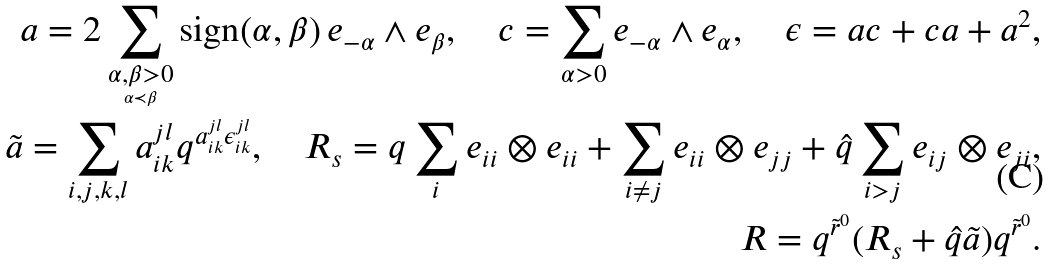<formula> <loc_0><loc_0><loc_500><loc_500>a = 2 \sum _ { \underset { \alpha \prec \beta } { \alpha , \beta > 0 } } \text {sign} ( \alpha , \beta ) \, e _ { - \alpha } \wedge e _ { \beta } , \quad c = \sum _ { \alpha > 0 } e _ { - \alpha } \wedge e _ { \alpha } , \quad \epsilon = a c + c a + a ^ { 2 } , \\ \tilde { a } = \sum _ { i , j , k , l } a _ { i k } ^ { j l } q ^ { a _ { i k } ^ { j l } \epsilon _ { i k } ^ { j l } } , \quad R _ { s } = q \sum _ { i } e _ { i i } \otimes e _ { i i } + \sum _ { i \neq j } e _ { i i } \otimes e _ { j j } + \hat { q } \sum _ { i > j } e _ { i j } \otimes e _ { j i } , \\ R = q ^ { \tilde { r } ^ { 0 } } ( R _ { s } + \hat { q } \tilde { a } ) q ^ { \tilde { r } ^ { 0 } } .</formula> 